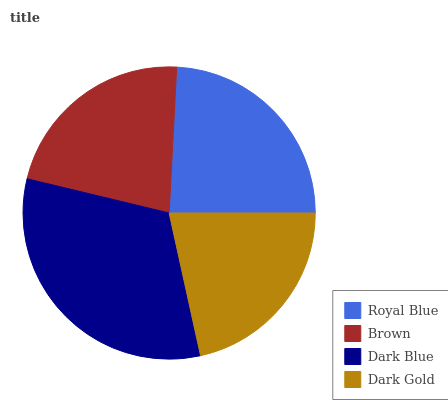Is Dark Gold the minimum?
Answer yes or no. Yes. Is Dark Blue the maximum?
Answer yes or no. Yes. Is Brown the minimum?
Answer yes or no. No. Is Brown the maximum?
Answer yes or no. No. Is Royal Blue greater than Brown?
Answer yes or no. Yes. Is Brown less than Royal Blue?
Answer yes or no. Yes. Is Brown greater than Royal Blue?
Answer yes or no. No. Is Royal Blue less than Brown?
Answer yes or no. No. Is Royal Blue the high median?
Answer yes or no. Yes. Is Brown the low median?
Answer yes or no. Yes. Is Brown the high median?
Answer yes or no. No. Is Dark Gold the low median?
Answer yes or no. No. 